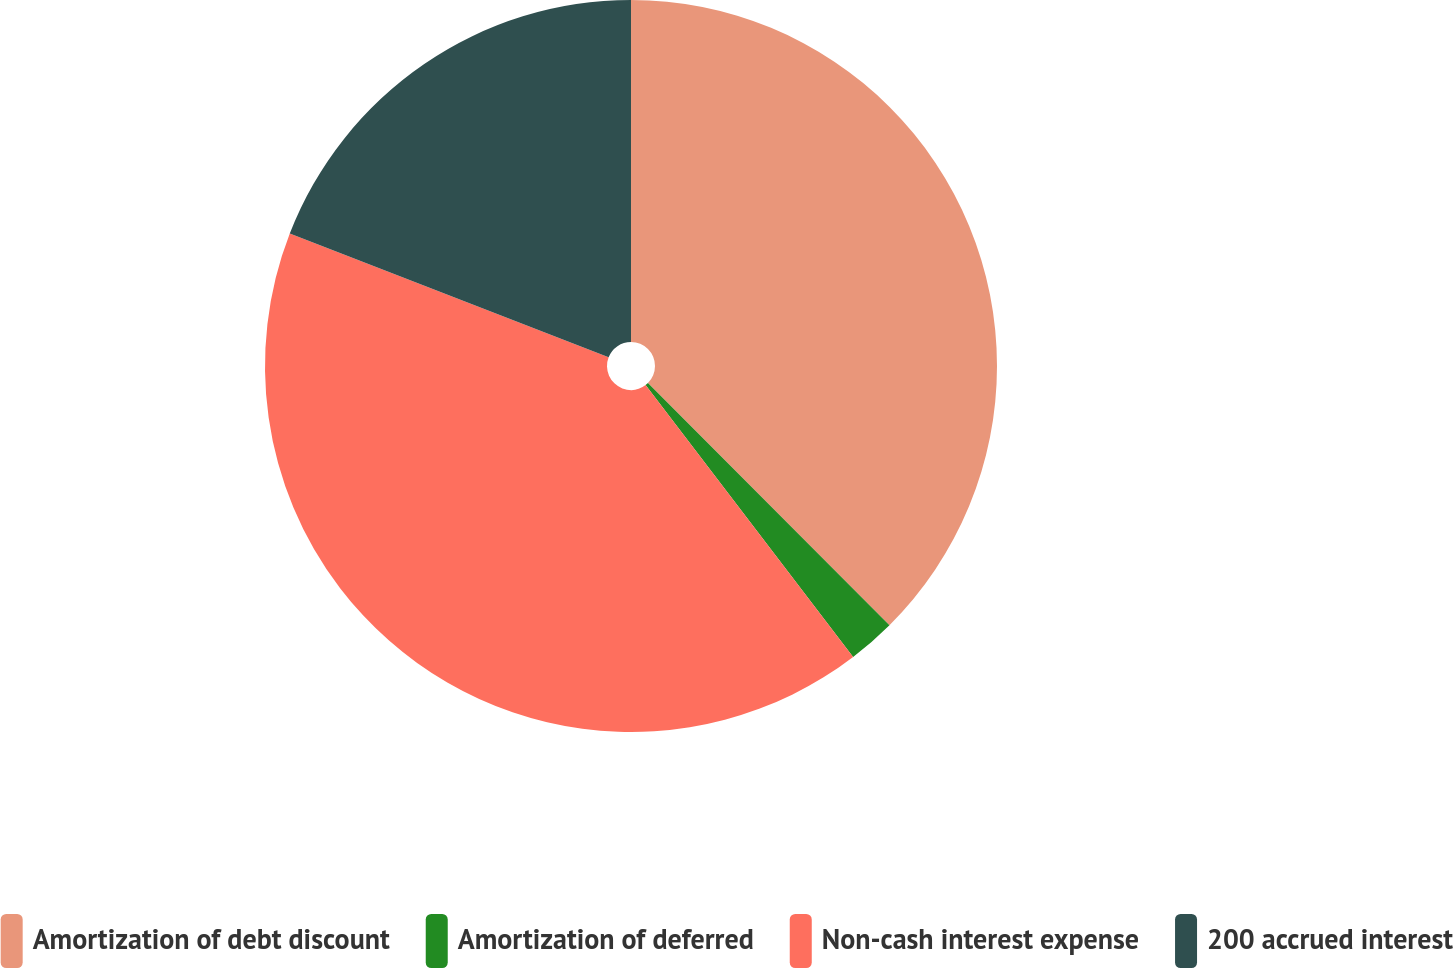<chart> <loc_0><loc_0><loc_500><loc_500><pie_chart><fcel>Amortization of debt discount<fcel>Amortization of deferred<fcel>Non-cash interest expense<fcel>200 accrued interest<nl><fcel>37.52%<fcel>2.1%<fcel>41.27%<fcel>19.11%<nl></chart> 